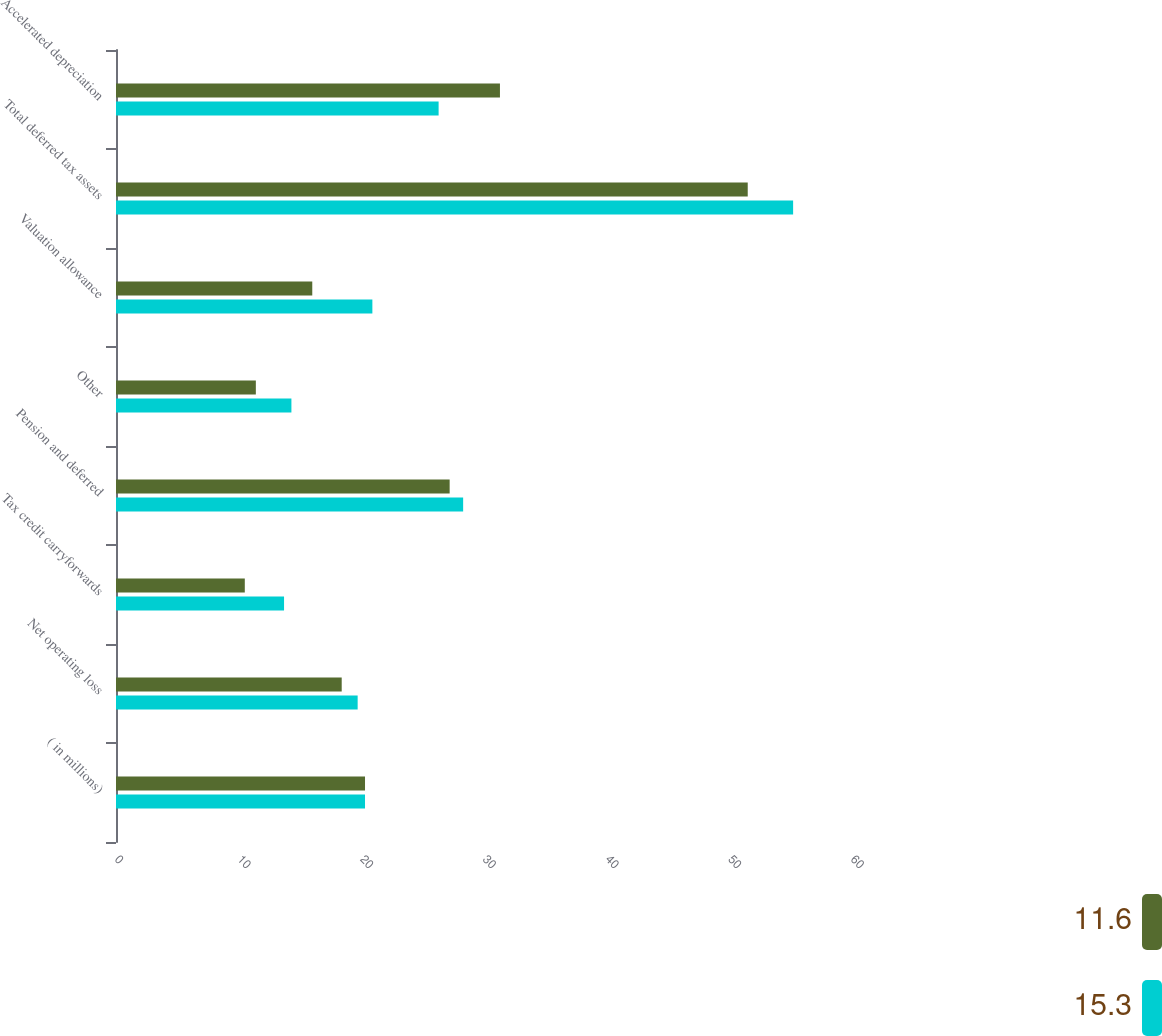Convert chart. <chart><loc_0><loc_0><loc_500><loc_500><stacked_bar_chart><ecel><fcel>( in millions)<fcel>Net operating loss<fcel>Tax credit carryforwards<fcel>Pension and deferred<fcel>Other<fcel>Valuation allowance<fcel>Total deferred tax assets<fcel>Accelerated depreciation<nl><fcel>11.6<fcel>20.3<fcel>18.4<fcel>10.5<fcel>27.2<fcel>11.4<fcel>16<fcel>51.5<fcel>31.3<nl><fcel>15.3<fcel>20.3<fcel>19.7<fcel>13.7<fcel>28.3<fcel>14.3<fcel>20.9<fcel>55.2<fcel>26.3<nl></chart> 